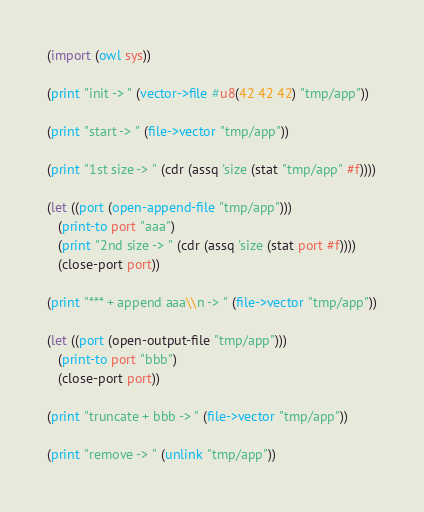Convert code to text. <code><loc_0><loc_0><loc_500><loc_500><_Scheme_>
(import (owl sys))

(print "init -> " (vector->file #u8(42 42 42) "tmp/app"))

(print "start -> " (file->vector "tmp/app"))

(print "1st size -> " (cdr (assq 'size (stat "tmp/app" #f))))

(let ((port (open-append-file "tmp/app")))
   (print-to port "aaa")
   (print "2nd size -> " (cdr (assq 'size (stat port #f))))
   (close-port port))

(print "*** + append aaa\\n -> " (file->vector "tmp/app"))

(let ((port (open-output-file "tmp/app")))
   (print-to port "bbb")
   (close-port port))

(print "truncate + bbb -> " (file->vector "tmp/app"))

(print "remove -> " (unlink "tmp/app"))
</code> 